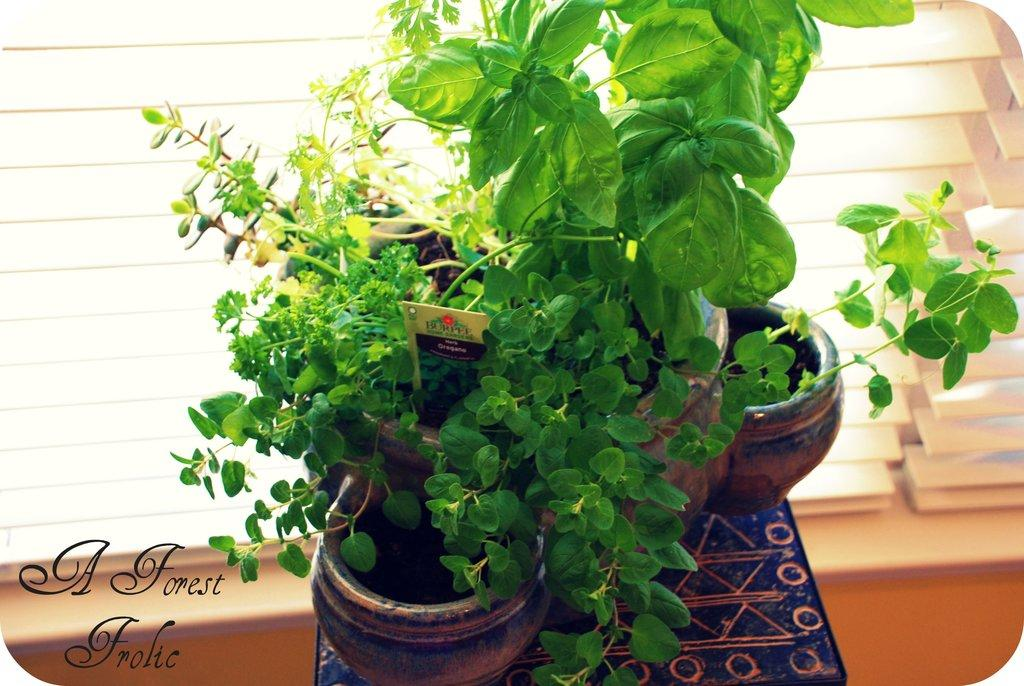What objects are on the table in the image? There are plant pots on the table in the image. What can be seen in front of the plant pots? There is a window in front of the plant pots. Where is the text located in the image? The text is at the bottom left side of the image. What type of knowledge is being shared through the room in the image? There is no room present in the image, and therefore no knowledge can be shared through it. 